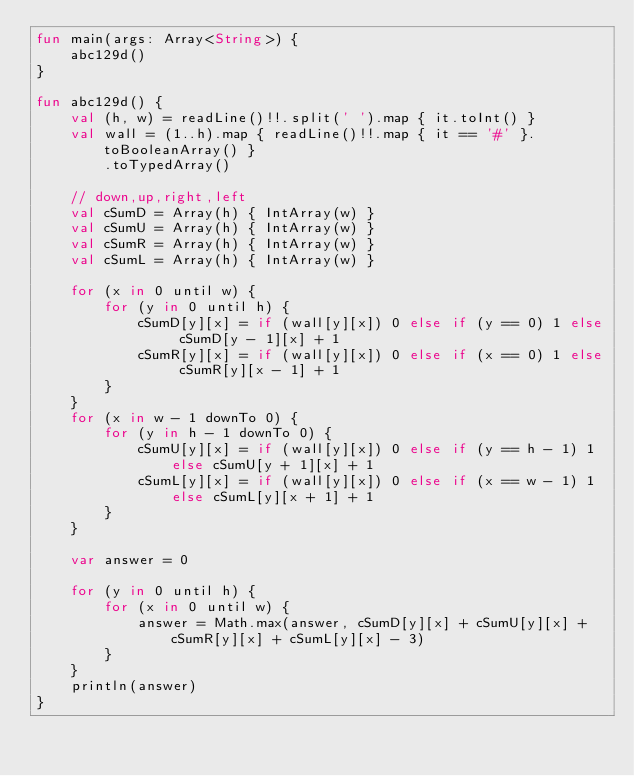<code> <loc_0><loc_0><loc_500><loc_500><_Kotlin_>fun main(args: Array<String>) {
    abc129d()
}

fun abc129d() {
    val (h, w) = readLine()!!.split(' ').map { it.toInt() }
    val wall = (1..h).map { readLine()!!.map { it == '#' }.toBooleanArray() }
        .toTypedArray()

    // down,up,right,left
    val cSumD = Array(h) { IntArray(w) }
    val cSumU = Array(h) { IntArray(w) }
    val cSumR = Array(h) { IntArray(w) }
    val cSumL = Array(h) { IntArray(w) }

    for (x in 0 until w) {
        for (y in 0 until h) {
            cSumD[y][x] = if (wall[y][x]) 0 else if (y == 0) 1 else cSumD[y - 1][x] + 1
            cSumR[y][x] = if (wall[y][x]) 0 else if (x == 0) 1 else cSumR[y][x - 1] + 1
        }
    }
    for (x in w - 1 downTo 0) {
        for (y in h - 1 downTo 0) {
            cSumU[y][x] = if (wall[y][x]) 0 else if (y == h - 1) 1 else cSumU[y + 1][x] + 1
            cSumL[y][x] = if (wall[y][x]) 0 else if (x == w - 1) 1 else cSumL[y][x + 1] + 1
        }
    }

    var answer = 0

    for (y in 0 until h) {
        for (x in 0 until w) {
            answer = Math.max(answer, cSumD[y][x] + cSumU[y][x] + cSumR[y][x] + cSumL[y][x] - 3)
        }
    }
    println(answer)
}
</code> 